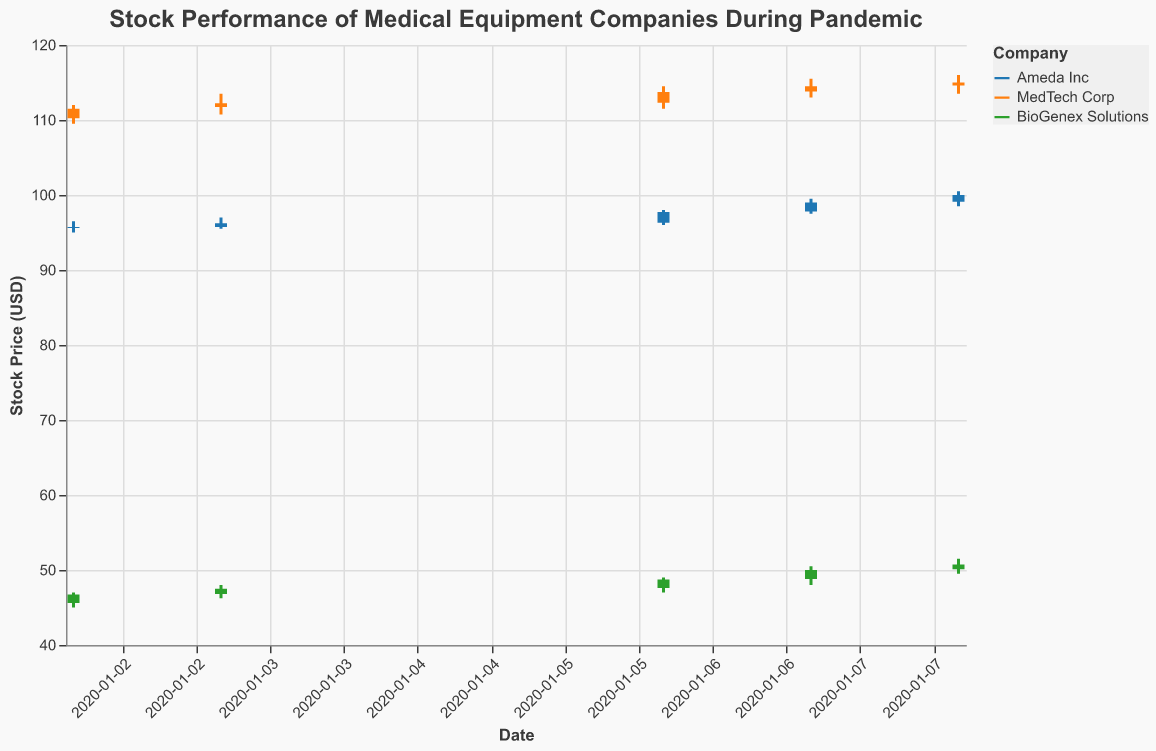How many companies' stock performances are represented in the plot? The legend on the right side of the plot lists the names of the companies, which are Ameda Inc, MedTech Corp, and BioGenex Solutions. This indicates that three companies are represented.
Answer: 3 Which company had the highest closing stock price on January 8, 2020? By looking at the data points for each company on January 8, 2020, MedTech Corp had a closing price of $115.00, Ameda Inc had $100.00, and BioGenex Solutions had $50.75. The highest closing price is from MedTech Corp.
Answer: MedTech Corp What is the overall trend in the stock price for Ameda Inc over the plotted dates? By following the opening and closing prices for Ameda Inc from January 2 to January 8, 2020, it shows a general upward trend, starting at $95.60 on January 2 and closing at $100.00 on January 8.
Answer: Upward trend Which company had the most significant stock price increase from January 2 to January 8, 2020? To determine the most significant increase, we calculate the difference between the closing price on January 8 and the opening price on January 2 for each company. For Ameda Inc, $100.00 - $95.60 = $4.40. For MedTech Corp, $115.00 - $110.25 = $4.75. For BioGenex Solutions, $50.75 - $45.60 = $5.15. BioGenex Solutions had the most significant increase.
Answer: BioGenex Solutions What was the lowest stock price for MedTech Corp during the entire period shown? By examining the low prices for MedTech Corp from January 2 to January 8, 2020, the lowest price was $109.50 on January 2.
Answer: $109.50 Which day saw the highest trading volume for BioGenex Solutions? By looking at the provided volumes, BioGenex Solutions had the highest volume on January 8, 2020, with a volume of 270,000.
Answer: January 8, 2020 How does the closing price on January 6, 2020, compare between Ameda Inc and BioGenex Solutions? The closing price for Ameda Inc on January 6 was $97.75, and for BioGenex Solutions, it was $48.75. Comparing these values, Ameda Inc's closing price was higher.
Answer: Ameda Inc's was higher What was the largest intraday range for Ameda Inc during this period? The intraday range is computed as the high minus the low price for each day. The largest intraday range for Ameda Inc occurred on January 8, 2020, with a high of $100.50 and a low of $98.50, giving a range of $2.00.
Answer: $2.00 Did MedTech Corp ever have a day where it closed at a higher price than it opened during this period? By examining the opening and closing prices for MedTech Corp from January 2 to January 8, 2020, it closed higher than it opened on January 6 ($113.75 close, $112.30 open) and on January 8 ($115.00 close, $114.60 open).
Answer: Yes 